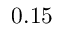Convert formula to latex. <formula><loc_0><loc_0><loc_500><loc_500>0 . 1 5</formula> 